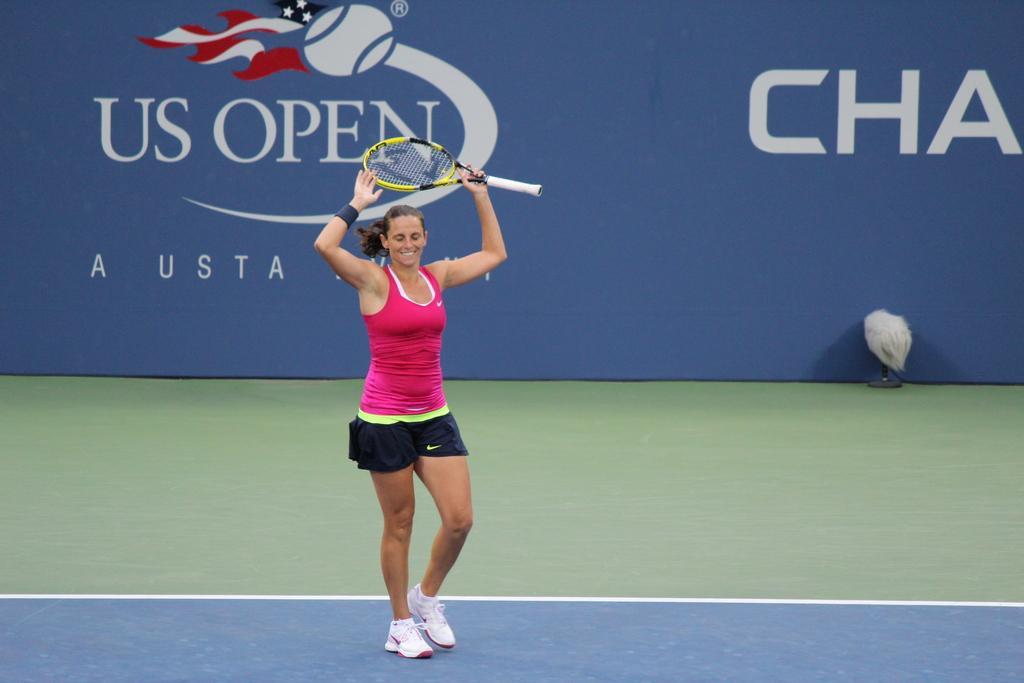In one or two sentences, can you explain what this image depicts? It is a tennis ground a woman is holding bat in her left hand she is smiling she is wearing white color shoes in the background there is a blue color banner. 